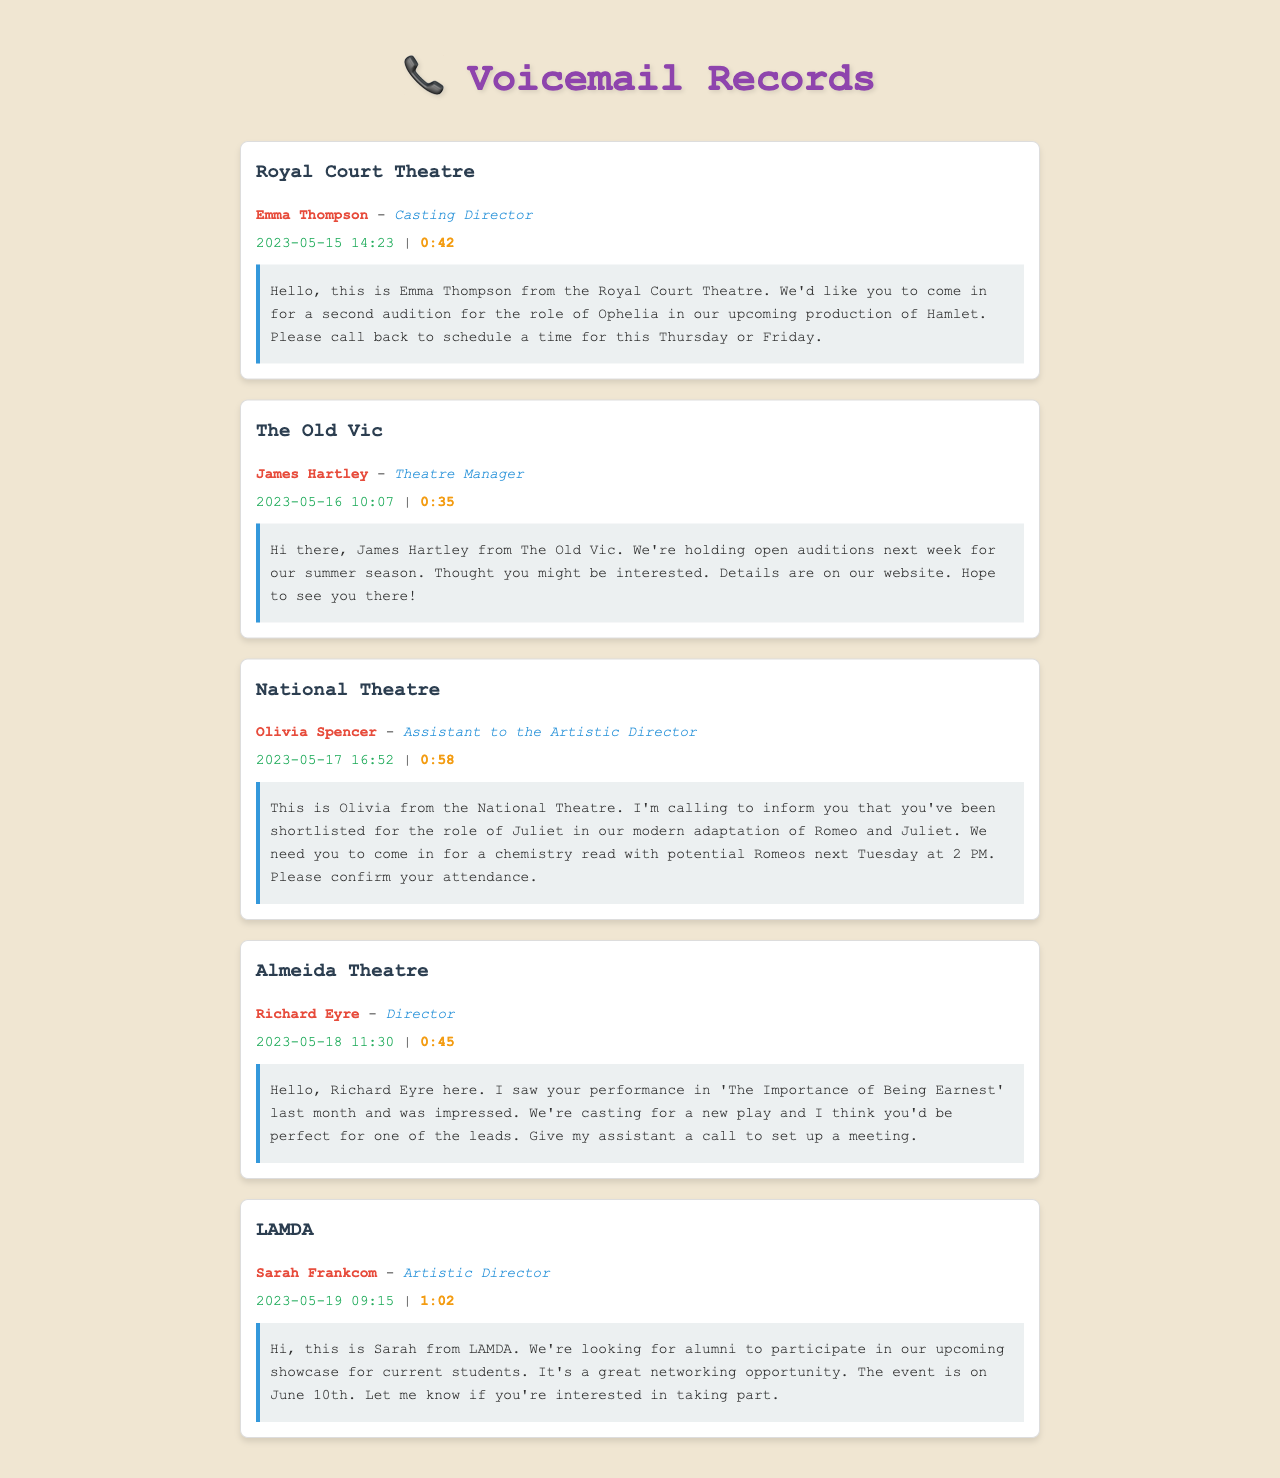What is the caller's name from the Royal Court Theatre? The voicemail identifies Emma Thompson as the caller from the Royal Court Theatre.
Answer: Emma Thompson Which role is being auditioned for at the Royal Court Theatre? The voicemail mentions that the audition is for the role of Ophelia in Hamlet.
Answer: Ophelia What date and time was the voicemail from James Hartley? The voicemail indicates it was left on May 16 at 10:07 AM.
Answer: 2023-05-16 10:07 How long is the voicemail from Olivia Spencer? The duration of the voicemail from Olivia Spencer is 58 seconds.
Answer: 0:58 What is the name of the theatre where Richard Eyre works? The voicemail identifies Almeida Theatre as the theatre where Richard Eyre works.
Answer: Almeida Theatre What is the date of the event organized by LAMDA? The voicemail states that the event is on June 10th.
Answer: June 10th Which casting role did Olivia Spencer mention in her voicemail? The voicemail indicates that Olivia Spencer is calling about the role of Juliet.
Answer: Juliet Who should be contacted to set up a meeting with Richard Eyre? Richard Eyre mentions that his assistant should be contacted.
Answer: His assistant How many voicemails mention an audition? Three voicemails refer to auditions, as seen in the messages from Emma Thompson, Olivia Spencer, and James Hartley.
Answer: Three 